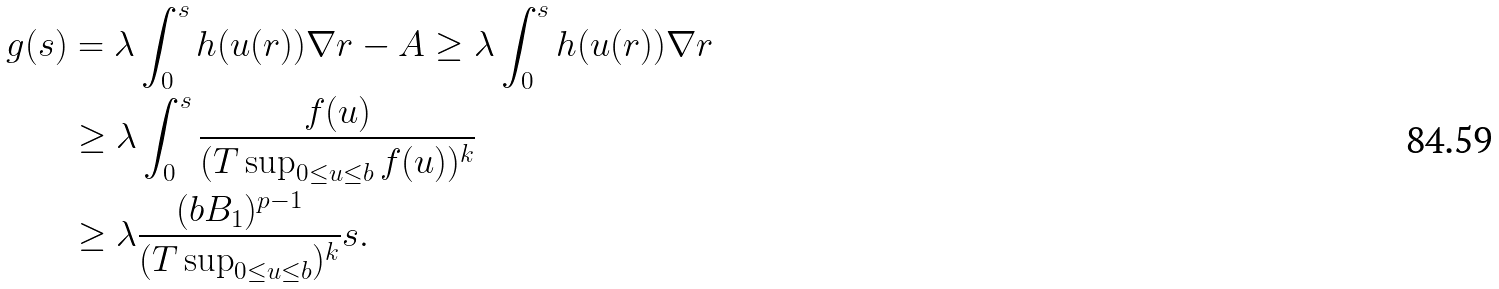Convert formula to latex. <formula><loc_0><loc_0><loc_500><loc_500>g ( s ) & = \lambda \int _ { 0 } ^ { s } h ( u ( r ) ) \nabla r - A \geq \lambda \int _ { 0 } ^ { s } h ( u ( r ) ) \nabla r \\ & \geq \lambda \int _ { 0 } ^ { s } \frac { f ( u ) } { ( T \sup _ { 0 \leq u \leq b } f ( u ) ) ^ { k } } \\ & \geq \lambda \frac { ( b B _ { 1 } ) ^ { p - 1 } } { ( T \sup _ { 0 \leq u \leq b } ) ^ { k } } s . \\</formula> 